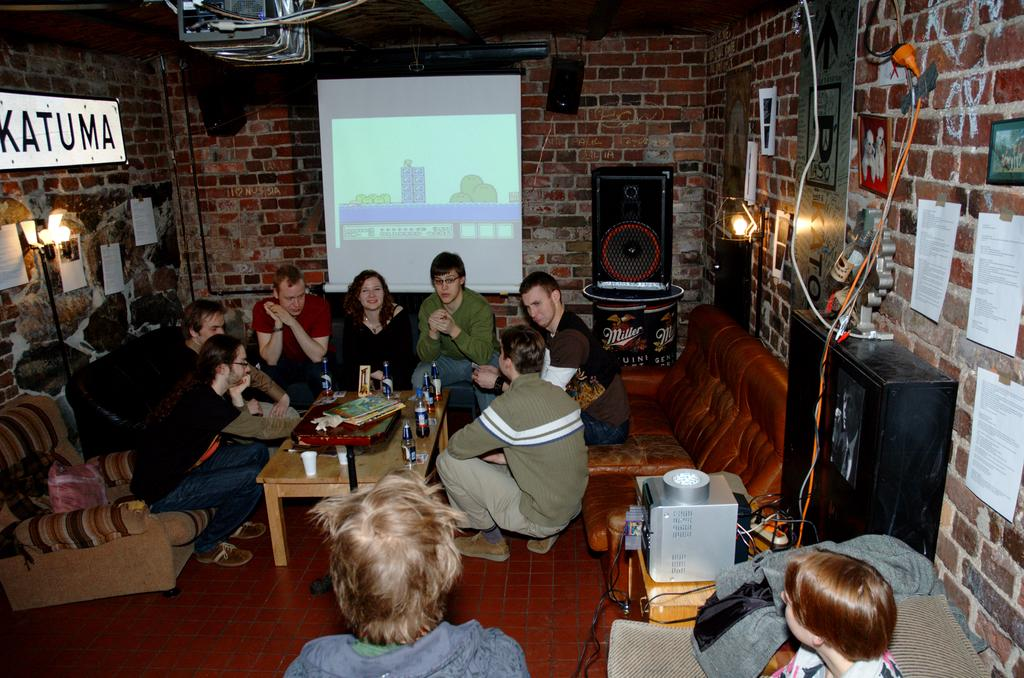What is happening in the image? There is a group of people in the image, and they are sitting around a table. What are the people doing while sitting around the table? The people are talking among themselves. What does the smell of the school have to do with the people sitting around the table in the image? There is no mention of a school or any smell in the image, so it is not possible to connect the two. 